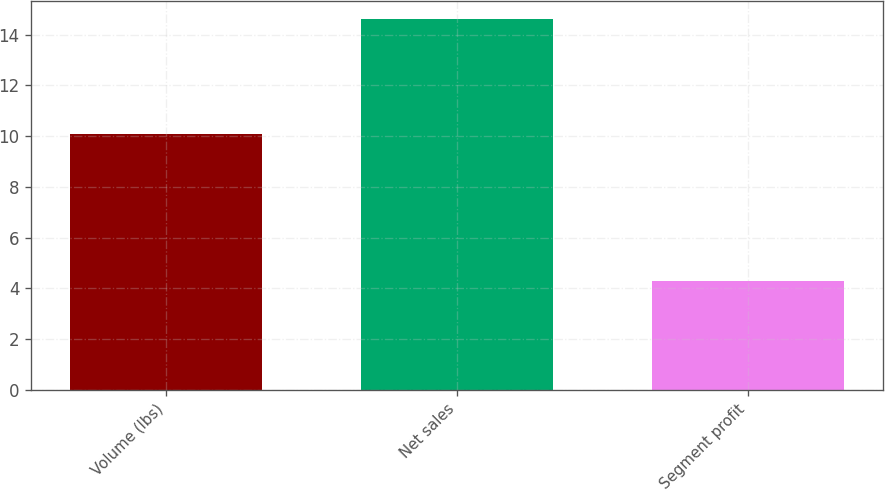Convert chart to OTSL. <chart><loc_0><loc_0><loc_500><loc_500><bar_chart><fcel>Volume (lbs)<fcel>Net sales<fcel>Segment profit<nl><fcel>10.1<fcel>14.6<fcel>4.3<nl></chart> 